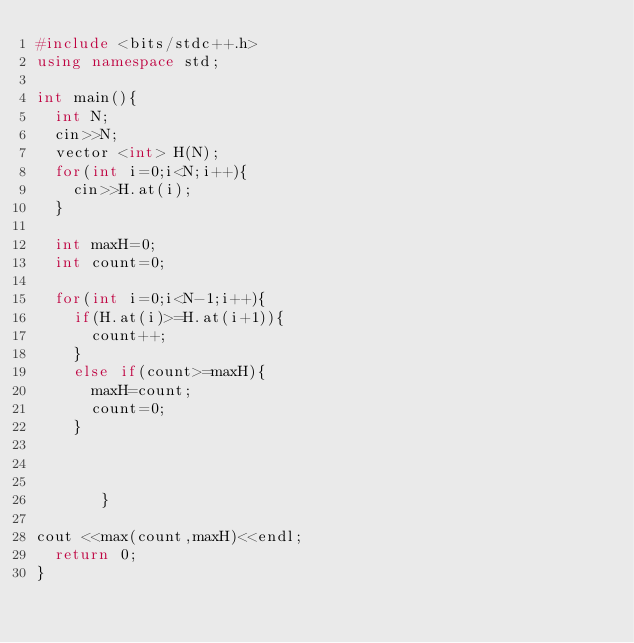Convert code to text. <code><loc_0><loc_0><loc_500><loc_500><_C++_>#include <bits/stdc++.h>
using namespace std;

int main(){
  int N;
  cin>>N;
  vector <int> H(N);
  for(int i=0;i<N;i++){
    cin>>H.at(i);
  }
  
  int maxH=0;
  int count=0;
  
  for(int i=0;i<N-1;i++){
    if(H.at(i)>=H.at(i+1)){
      count++;
    }
    else if(count>=maxH){
      maxH=count;
      count=0;
    }
    
    
    
       }
       
cout <<max(count,maxH)<<endl;
  return 0;
}

  
</code> 